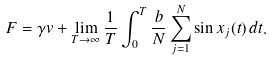Convert formula to latex. <formula><loc_0><loc_0><loc_500><loc_500>F = \gamma v + \lim _ { T \to \infty } \frac { 1 } { T } \int _ { 0 } ^ { T } \frac { b } { N } \sum _ { j = 1 } ^ { N } \sin x _ { j } ( t ) \, d t .</formula> 